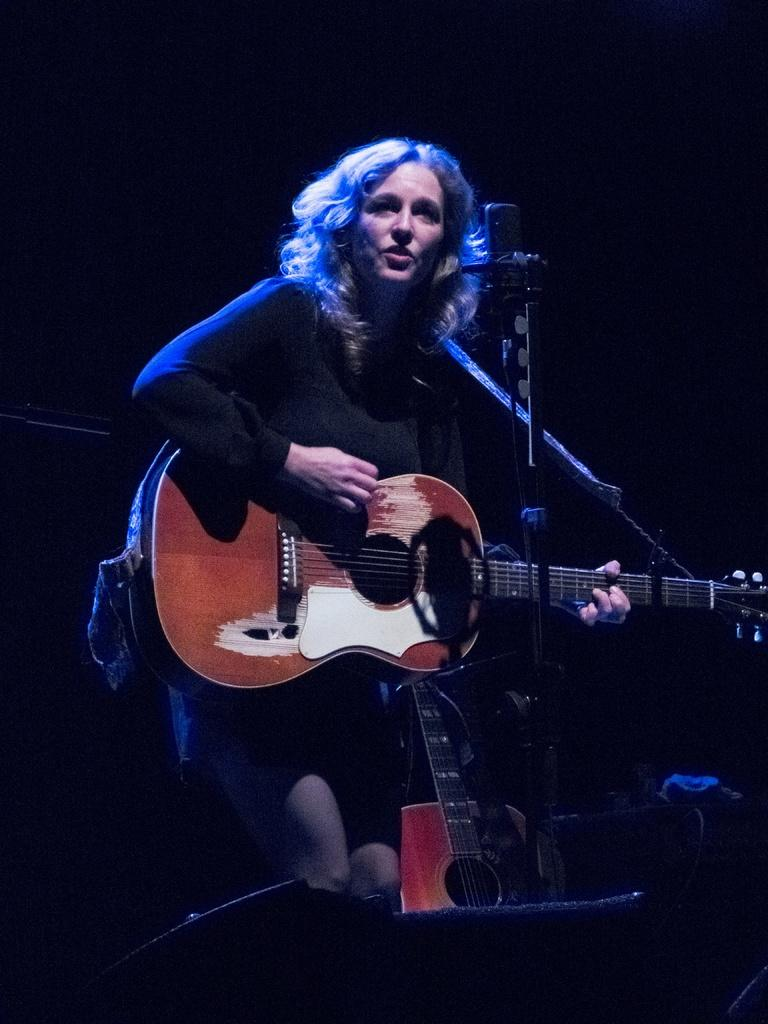Who is the main subject in the image? There is a lady in the image. What is the lady holding in the image? The lady is holding a guitar. What object is in front of the lady? There is a microphone in front of the lady. What color is the lady's outfit in the image? The lady is dressed in black. How many fish can be seen swimming around the lady in the image? There are no fish present in the image. 